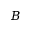Convert formula to latex. <formula><loc_0><loc_0><loc_500><loc_500>B</formula> 